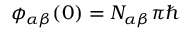<formula> <loc_0><loc_0><loc_500><loc_500>\phi _ { \alpha \beta } ( 0 ) = N _ { \alpha \beta } \pi \hbar</formula> 